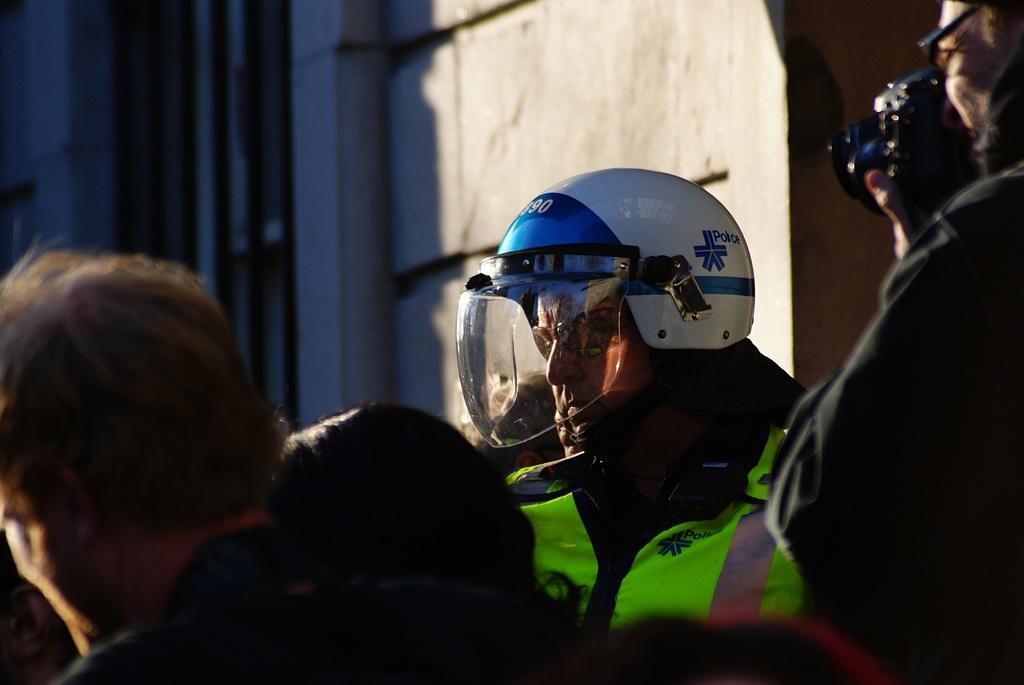What is happening in the image involving the people? There are people standing in the image, and one of them is holding a camera to take a picture. What can be seen on the man's head? The man is wearing a helmet on his head. What is the person holding the camera doing? The person holding the camera is taking a picture. What can be seen in the background of the image? There is a building visible in the background of the image. Can you tell me what the grandmother is doing in the image? There is no grandmother present in the image. What type of things can be seen flying around in the image? There are no things flying around in the image. 